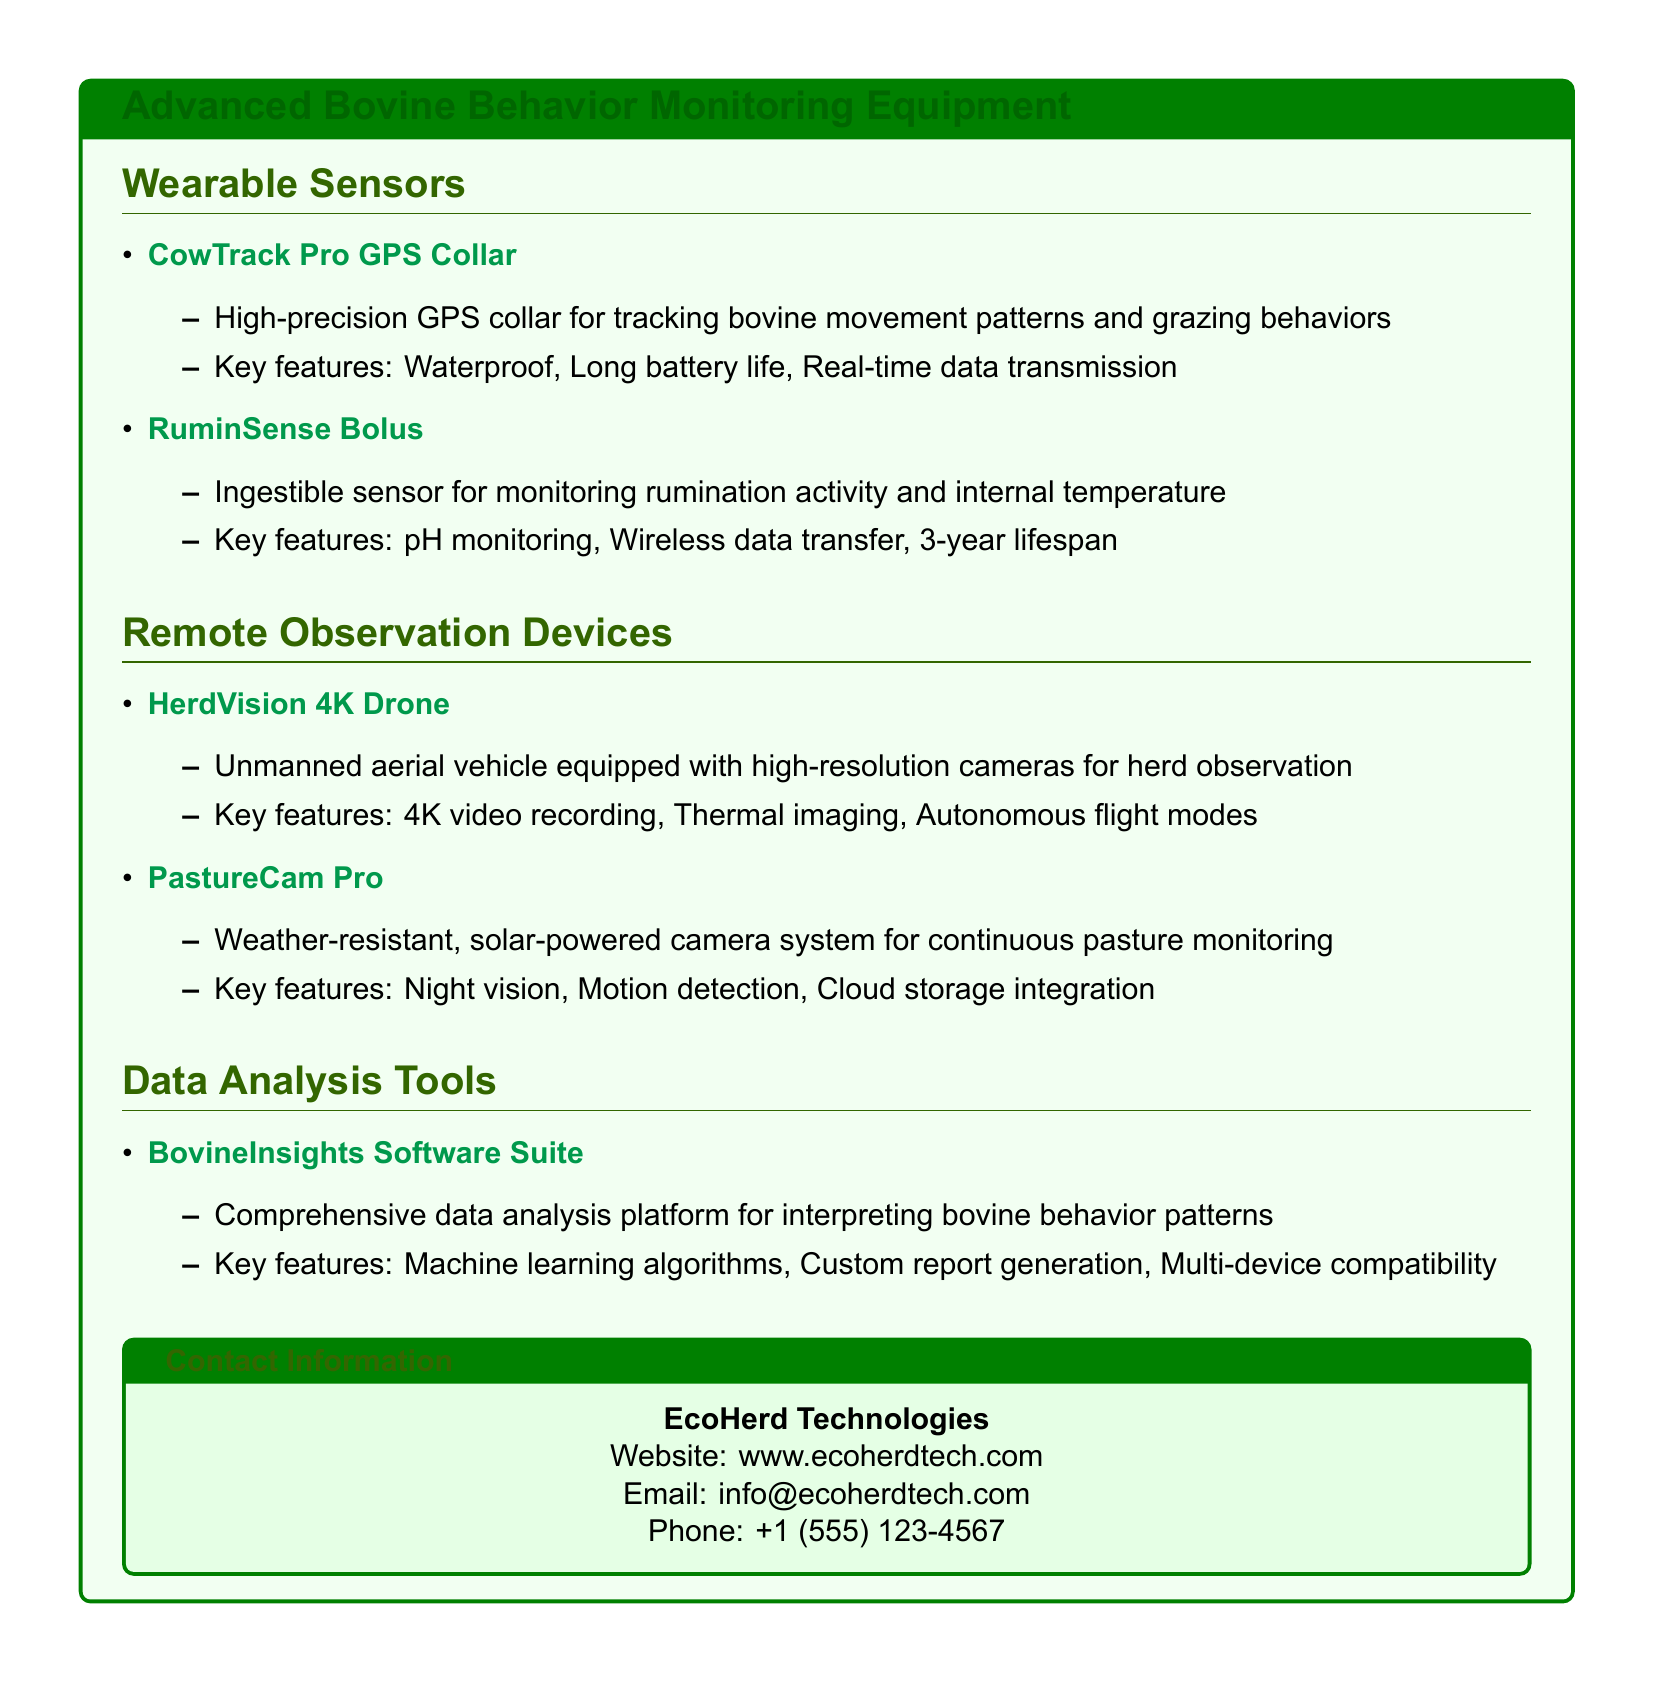What is the name of the GPS collar? The document lists the CowTrack Pro GPS Collar as a wearable sensor for tracking bovine movement.
Answer: CowTrack Pro GPS Collar What is the main function of the RuminSense Bolus? The RuminSense Bolus is primarily used for monitoring rumination activity and internal temperature in bovines.
Answer: Monitoring rumination activity and internal temperature What feature does the HerdVision 4K Drone offer? One of the key features of the HerdVision 4K Drone is its capability for 4K video recording.
Answer: 4K video recording How is the PastureCam Pro powered? The PastureCam Pro is a solar-powered camera system, allowing for continuous monitoring in pastures.
Answer: Solar-powered What is the lifespan of the RuminSense Bolus? The RuminSense Bolus has a lifespan of three years, as stated in the document.
Answer: 3-year lifespan Which software suite is mentioned for data analysis? The BovineInsights Software Suite is indicated as a comprehensive data analysis tool for bovine behavior patterns.
Answer: BovineInsights Software Suite What kind of imaging does the HerdVision 4K Drone include? The HerdVision 4K Drone includes thermal imaging as one of its key features.
Answer: Thermal imaging What type of data does the BovineInsights Software Suite utilize? The software utilizes machine learning algorithms to analyze bovine behavior patterns effectively.
Answer: Machine learning algorithms 